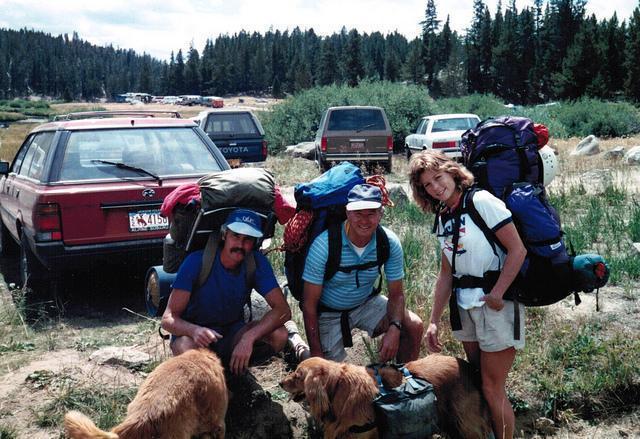What sort of adventure are they probably heading out on?
Choose the correct response, then elucidate: 'Answer: answer
Rationale: rationale.'
Options: Flying, riding, camping, swimming. Answer: camping.
Rationale: There is a nature scene in the background and they have camping backpacks on with visible sleeping bags as one would if they were going camping. 